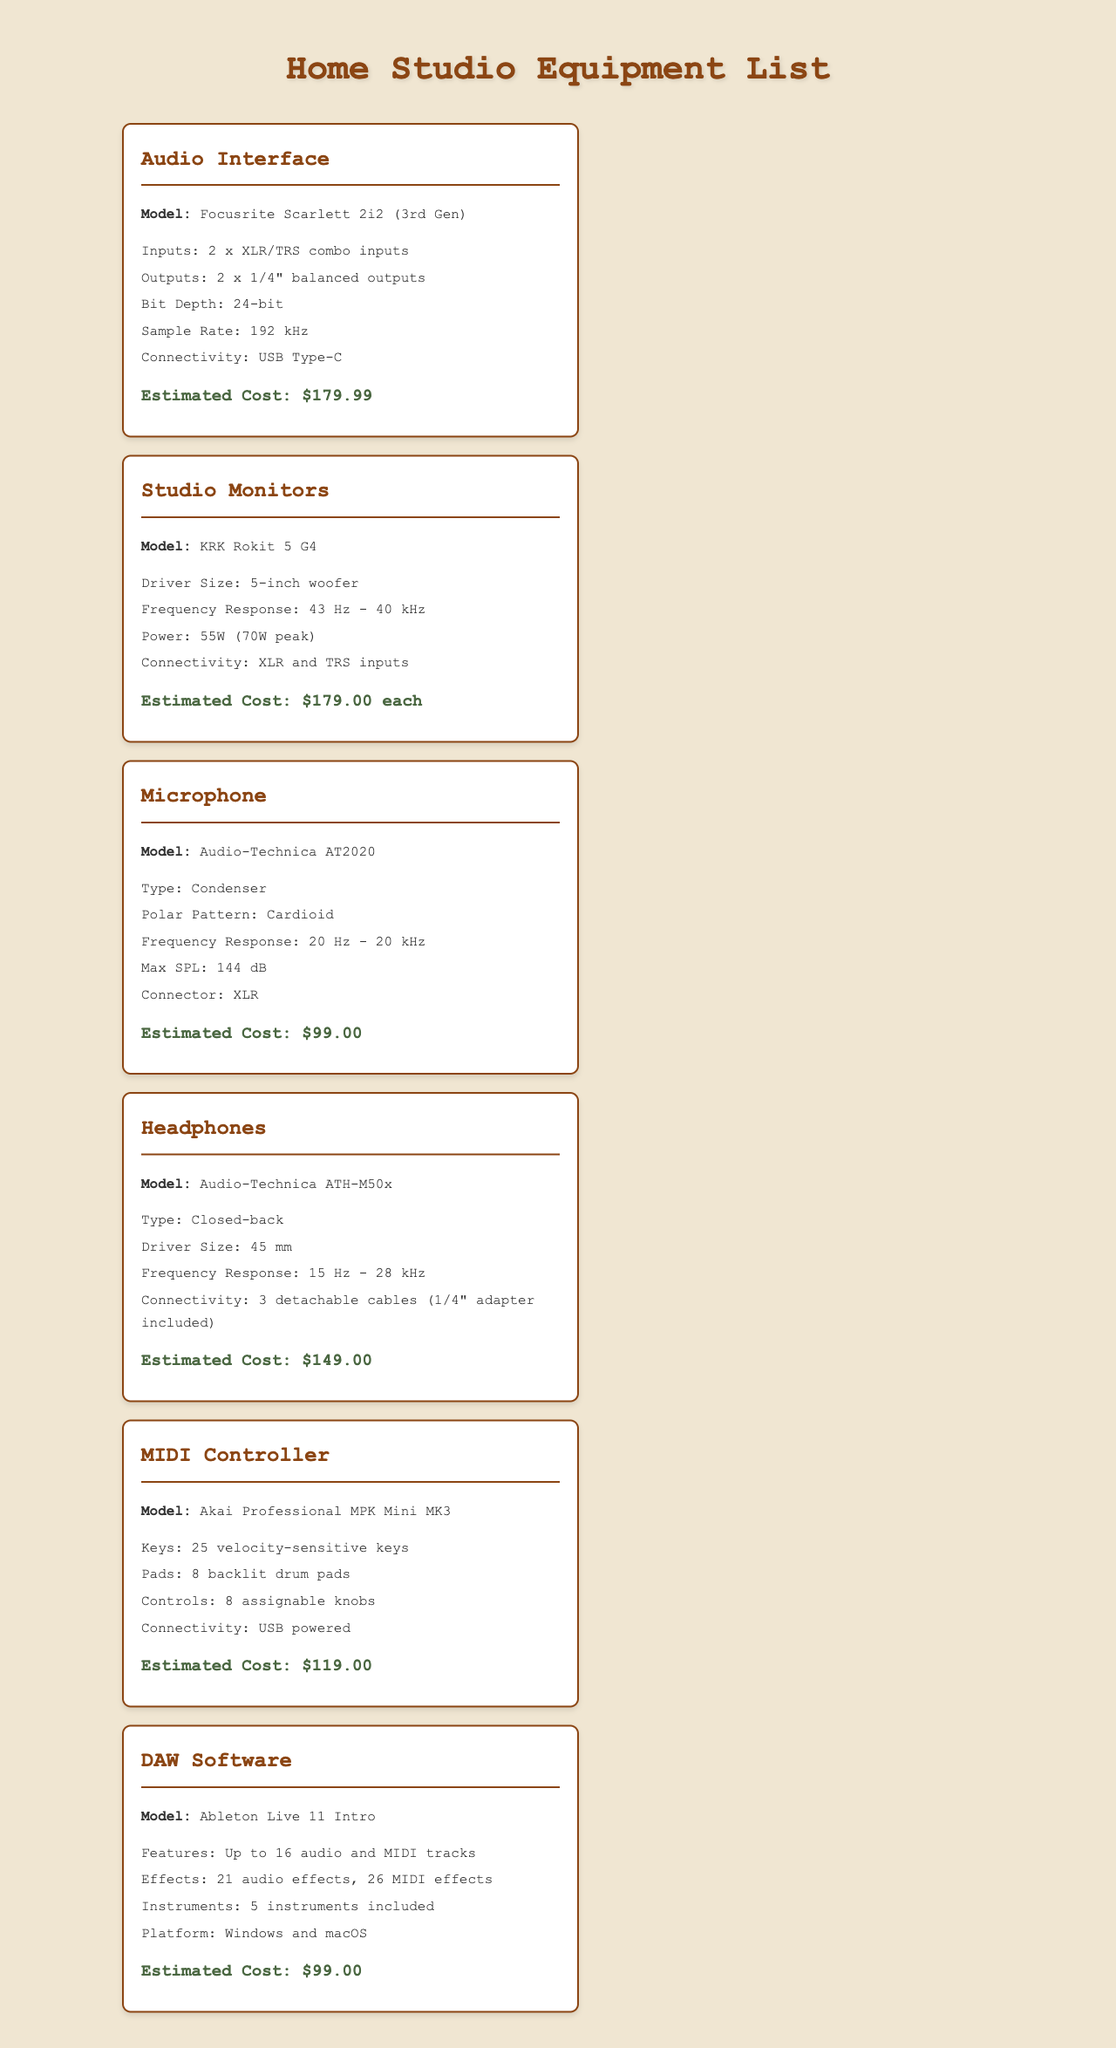what is the model of the audio interface? The audio interface is specified as the Focusrite Scarlett 2i2 (3rd Gen) in the document.
Answer: Focusrite Scarlett 2i2 (3rd Gen) how many inputs does the audio interface have? The audio interface has 2 x XLR/TRS combo inputs, as mentioned in the specifications.
Answer: 2 x XLR/TRS combo inputs what is the estimated cost of the studio monitors? The document states that the estimated cost of the studio monitors is $179.00 each.
Answer: $179.00 each what type of microphone is listed? The document specifies the type of microphone as a condenser type.
Answer: Condenser how many audio effects are included in the DAW software? The DAW software includes 21 audio effects, as described in the document.
Answer: 21 audio effects which MIDI controller model has backlit drum pads? The MIDI controller mentioned with backlit drum pads is the Akai Professional MPK Mini MK3.
Answer: Akai Professional MPK Mini MK3 what is the frequency response of the headphones? The headphones have a frequency response of 15 Hz - 28 kHz, as detailed in the document.
Answer: 15 Hz - 28 kHz what type of connector does the microphone use? The microphone uses an XLR connector, as per the specifications provided.
Answer: XLR how many velocity-sensitive keys are on the MIDI controller? The MIDI controller has 25 velocity-sensitive keys included in its specifications.
Answer: 25 velocity-sensitive keys 